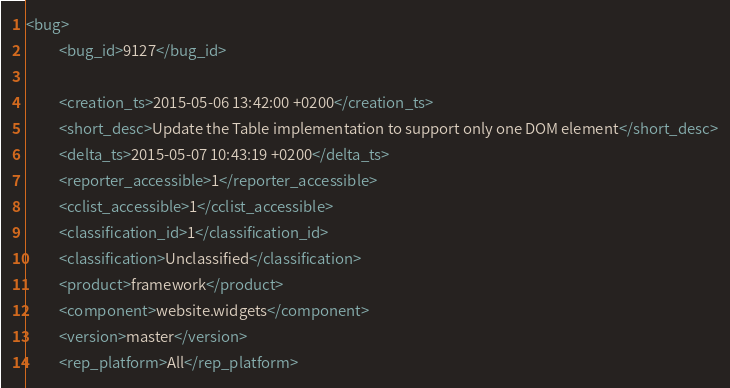Convert code to text. <code><loc_0><loc_0><loc_500><loc_500><_XML_><bug>
          <bug_id>9127</bug_id>
          
          <creation_ts>2015-05-06 13:42:00 +0200</creation_ts>
          <short_desc>Update the Table implementation to support only one DOM element</short_desc>
          <delta_ts>2015-05-07 10:43:19 +0200</delta_ts>
          <reporter_accessible>1</reporter_accessible>
          <cclist_accessible>1</cclist_accessible>
          <classification_id>1</classification_id>
          <classification>Unclassified</classification>
          <product>framework</product>
          <component>website.widgets</component>
          <version>master</version>
          <rep_platform>All</rep_platform></code> 